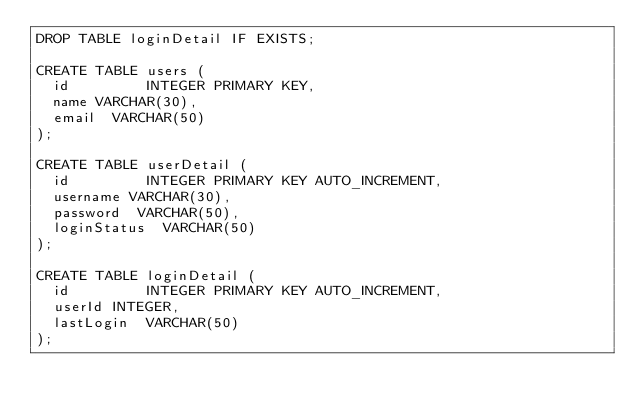Convert code to text. <code><loc_0><loc_0><loc_500><loc_500><_SQL_>DROP TABLE loginDetail IF EXISTS;

CREATE TABLE users (
  id         INTEGER PRIMARY KEY,
  name VARCHAR(30),
  email  VARCHAR(50)
);

CREATE TABLE userDetail (
  id         INTEGER PRIMARY KEY AUTO_INCREMENT,
  username VARCHAR(30),
  password  VARCHAR(50),
  loginStatus  VARCHAR(50)
);

CREATE TABLE loginDetail (
  id         INTEGER PRIMARY KEY AUTO_INCREMENT,
  userId INTEGER,
  lastLogin  VARCHAR(50)
);
</code> 